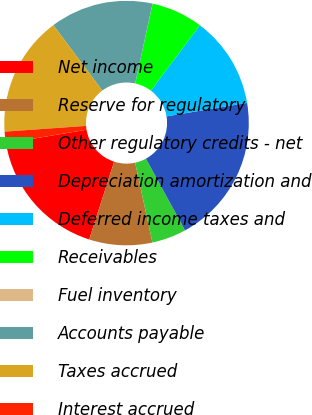Convert chart. <chart><loc_0><loc_0><loc_500><loc_500><pie_chart><fcel>Net income<fcel>Reserve for regulatory<fcel>Other regulatory credits - net<fcel>Depreciation amortization and<fcel>Deferred income taxes and<fcel>Receivables<fcel>Fuel inventory<fcel>Accounts payable<fcel>Taxes accrued<fcel>Interest accrued<nl><fcel>17.42%<fcel>8.34%<fcel>4.55%<fcel>19.69%<fcel>12.12%<fcel>6.82%<fcel>0.01%<fcel>13.63%<fcel>15.9%<fcel>1.52%<nl></chart> 